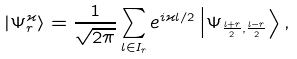Convert formula to latex. <formula><loc_0><loc_0><loc_500><loc_500>| \Psi _ { r } ^ { \varkappa } \rangle = \frac { 1 } { \sqrt { 2 \pi } } \sum _ { l \in I _ { r } } e ^ { i \varkappa l / 2 } \left | \Psi _ { \frac { l + r } { 2 } , \frac { l - r } { 2 } } \right \rangle ,</formula> 